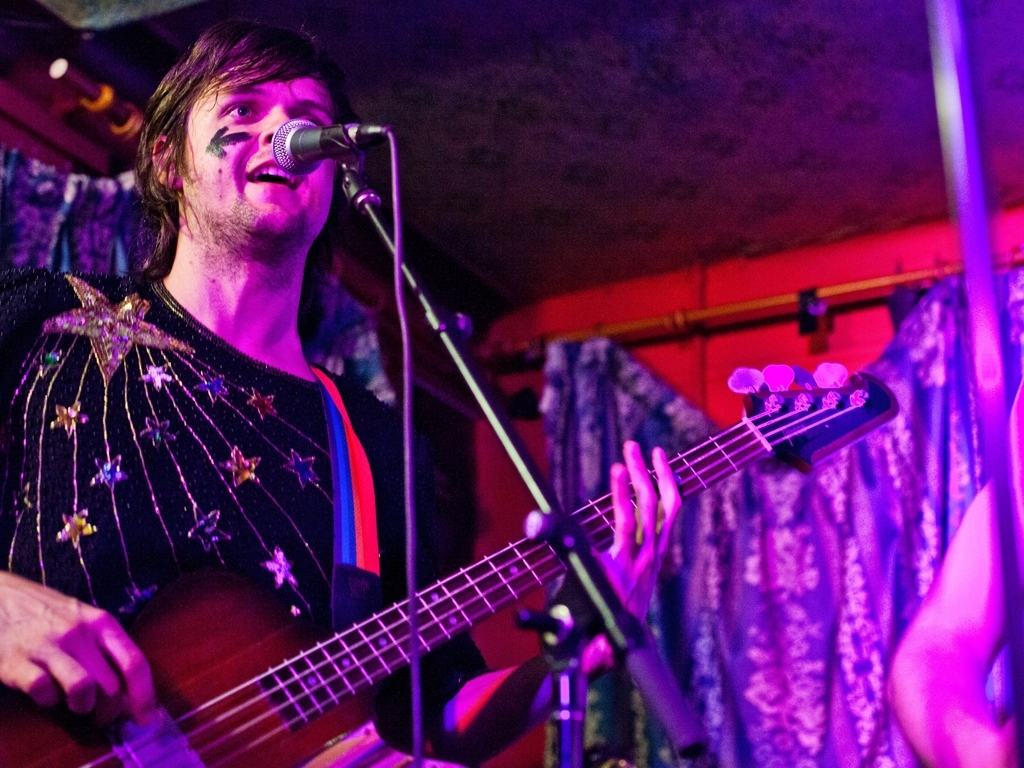Does the main subject lack details and texture? No, the main subject possesses clear details and texture. You can observe the intricate patterns on the outfit, the distinct strings on the guitar, and the subtle variations in lighting that give depth to the image. 